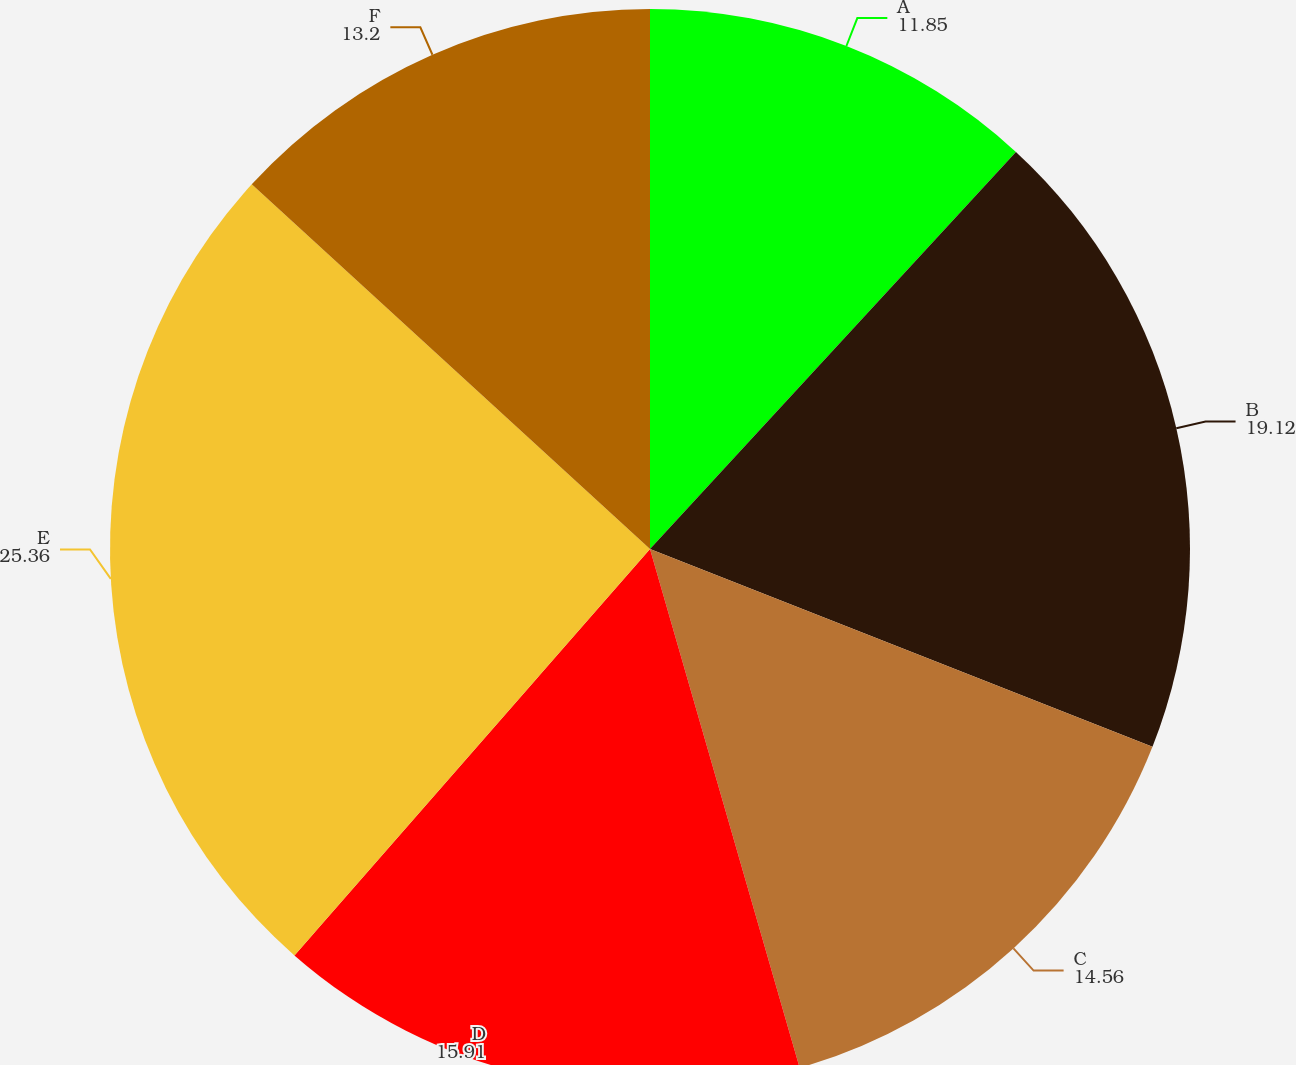Convert chart. <chart><loc_0><loc_0><loc_500><loc_500><pie_chart><fcel>A<fcel>B<fcel>C<fcel>D<fcel>E<fcel>F<nl><fcel>11.85%<fcel>19.12%<fcel>14.56%<fcel>15.91%<fcel>25.36%<fcel>13.2%<nl></chart> 